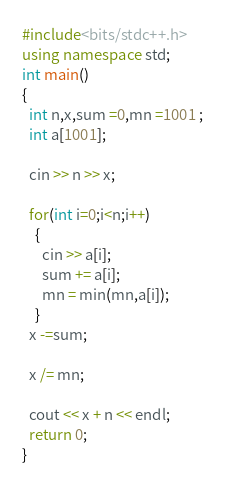<code> <loc_0><loc_0><loc_500><loc_500><_C++_>#include<bits/stdc++.h>
using namespace std;
int main()
{
  int n,x,sum =0,mn =1001 ;
  int a[1001];

  cin >> n >> x;

  for(int i=0;i<n;i++)
    {
      cin >> a[i];
      sum += a[i];
      mn = min(mn,a[i]);
    }
  x -=sum;

  x /= mn;

  cout << x + n << endl;
  return 0;
}
</code> 